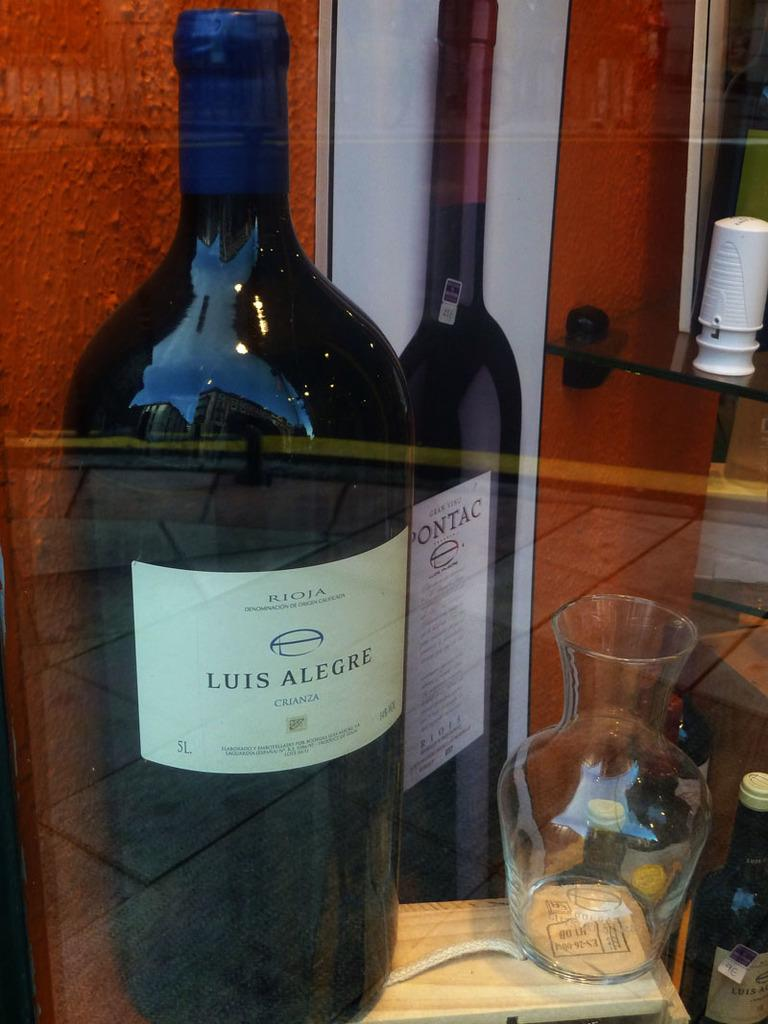Provide a one-sentence caption for the provided image. the bottle of Luis Alegre wine is sitting beside the carafe. 